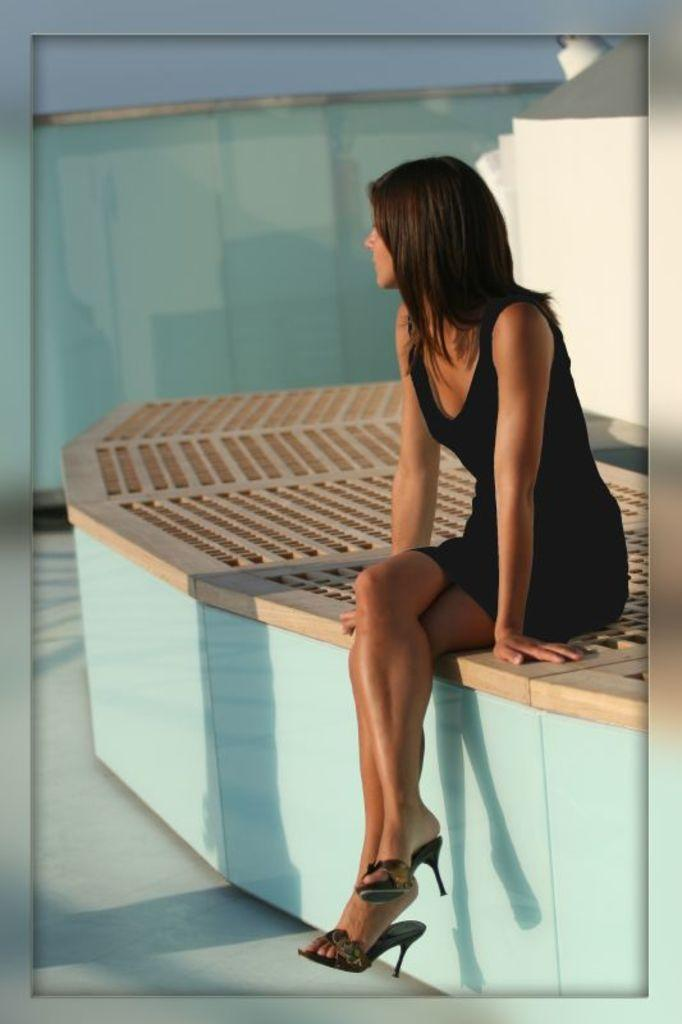What is the lady doing in the image? The lady is sitting on the white wall in the image. What can be seen on the wall besides the lady? There is a wooden object on the wall. What is visible in the background of the image? There is a glass railing and a white object in the background. What word is being spelled out by the lady on the stage in the image? There is no stage or word-spelling activity present in the image. 